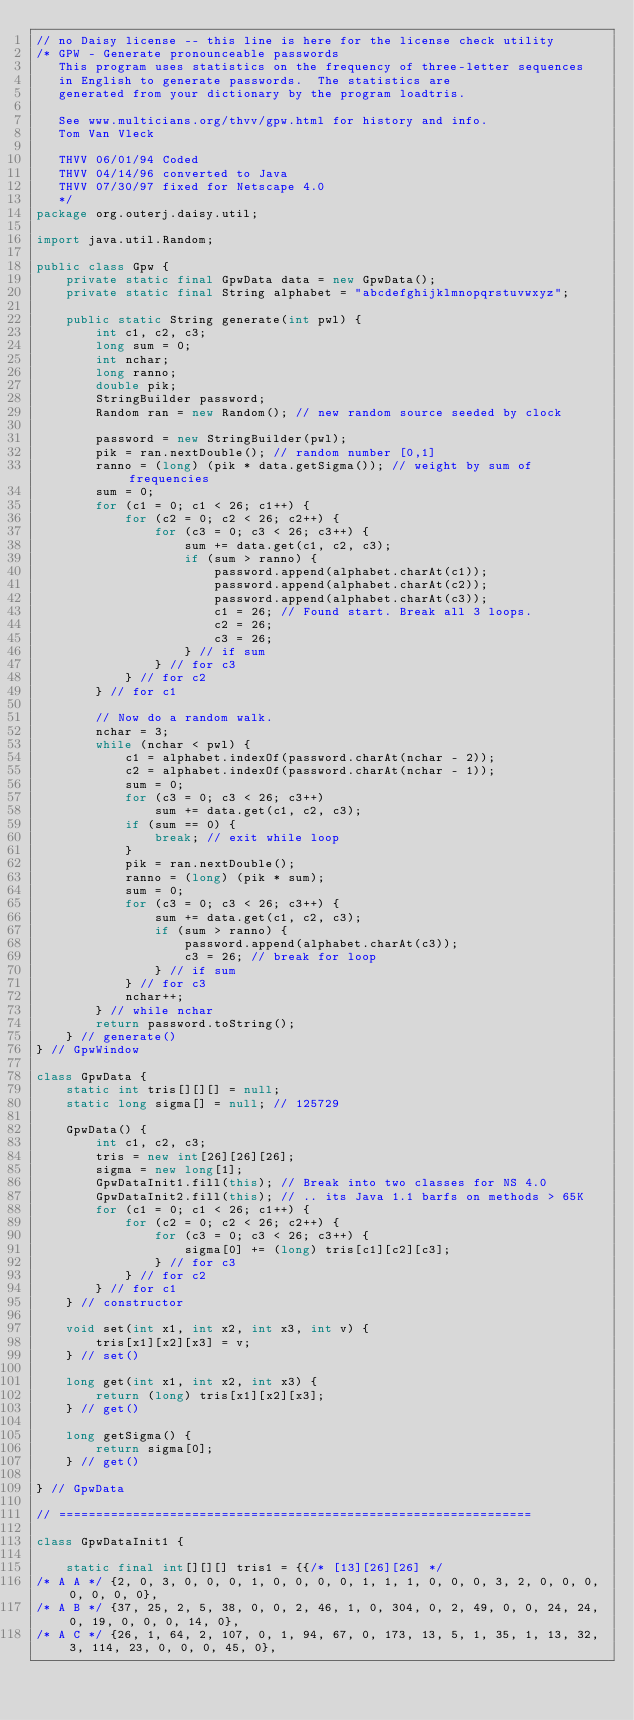<code> <loc_0><loc_0><loc_500><loc_500><_Java_>// no Daisy license -- this line is here for the license check utility
/* GPW - Generate pronounceable passwords
   This program uses statistics on the frequency of three-letter sequences
   in English to generate passwords.  The statistics are
   generated from your dictionary by the program loadtris.

   See www.multicians.org/thvv/gpw.html for history and info.
   Tom Van Vleck

   THVV 06/01/94 Coded
   THVV 04/14/96 converted to Java
   THVV 07/30/97 fixed for Netscape 4.0
   */
package org.outerj.daisy.util;

import java.util.Random;

public class Gpw {
    private static final GpwData data = new GpwData();
    private static final String alphabet = "abcdefghijklmnopqrstuvwxyz";

    public static String generate(int pwl) {
        int c1, c2, c3;
        long sum = 0;
        int nchar;
        long ranno;
        double pik;
        StringBuilder password;
        Random ran = new Random(); // new random source seeded by clock

        password = new StringBuilder(pwl);
        pik = ran.nextDouble(); // random number [0,1]
        ranno = (long) (pik * data.getSigma()); // weight by sum of frequencies
        sum = 0;
        for (c1 = 0; c1 < 26; c1++) {
            for (c2 = 0; c2 < 26; c2++) {
                for (c3 = 0; c3 < 26; c3++) {
                    sum += data.get(c1, c2, c3);
                    if (sum > ranno) {
                        password.append(alphabet.charAt(c1));
                        password.append(alphabet.charAt(c2));
                        password.append(alphabet.charAt(c3));
                        c1 = 26; // Found start. Break all 3 loops.
                        c2 = 26;
                        c3 = 26;
                    } // if sum
                } // for c3
            } // for c2
        } // for c1

        // Now do a random walk.
        nchar = 3;
        while (nchar < pwl) {
            c1 = alphabet.indexOf(password.charAt(nchar - 2));
            c2 = alphabet.indexOf(password.charAt(nchar - 1));
            sum = 0;
            for (c3 = 0; c3 < 26; c3++)
                sum += data.get(c1, c2, c3);
            if (sum == 0) {
                break; // exit while loop
            }
            pik = ran.nextDouble();
            ranno = (long) (pik * sum);
            sum = 0;
            for (c3 = 0; c3 < 26; c3++) {
                sum += data.get(c1, c2, c3);
                if (sum > ranno) {
                    password.append(alphabet.charAt(c3));
                    c3 = 26; // break for loop
                } // if sum
            } // for c3
            nchar++;
        } // while nchar
        return password.toString();
    } // generate()
} // GpwWindow

class GpwData {
    static int tris[][][] = null;
    static long sigma[] = null; // 125729

    GpwData() {
        int c1, c2, c3;
        tris = new int[26][26][26];
        sigma = new long[1];
        GpwDataInit1.fill(this); // Break into two classes for NS 4.0
        GpwDataInit2.fill(this); // .. its Java 1.1 barfs on methods > 65K
        for (c1 = 0; c1 < 26; c1++) {
            for (c2 = 0; c2 < 26; c2++) {
                for (c3 = 0; c3 < 26; c3++) {
                    sigma[0] += (long) tris[c1][c2][c3];
                } // for c3
            } // for c2
        } // for c1
    } // constructor

    void set(int x1, int x2, int x3, int v) {
        tris[x1][x2][x3] = v;
    } // set()

    long get(int x1, int x2, int x3) {
        return (long) tris[x1][x2][x3];
    } // get()

    long getSigma() {
        return sigma[0];
    } // get()

} // GpwData

// ================================================================

class GpwDataInit1 {

    static final int[][][] tris1 = {{/* [13][26][26] */
/* A A */ {2, 0, 3, 0, 0, 0, 1, 0, 0, 0, 0, 1, 1, 1, 0, 0, 0, 3, 2, 0, 0, 0, 0, 0, 0, 0},
/* A B */ {37, 25, 2, 5, 38, 0, 0, 2, 46, 1, 0, 304, 0, 2, 49, 0, 0, 24, 24, 0, 19, 0, 0, 0, 14, 0},
/* A C */ {26, 1, 64, 2, 107, 0, 1, 94, 67, 0, 173, 13, 5, 1, 35, 1, 13, 32, 3, 114, 23, 0, 0, 0, 45, 0},</code> 